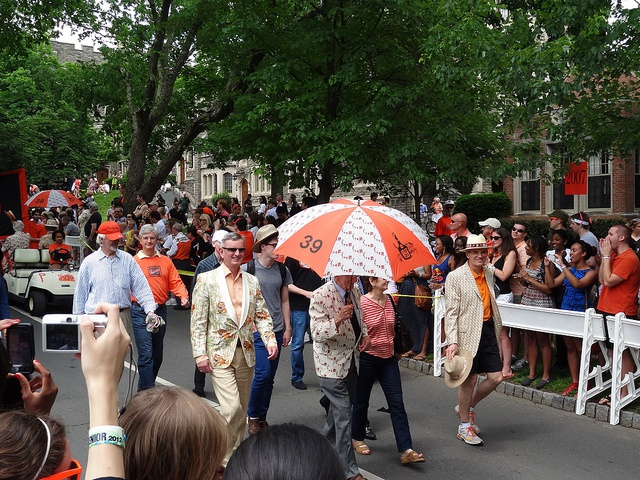Describe the objects in this image and their specific colors. I can see people in darkgreen, black, gray, and maroon tones, umbrella in darkgreen, white, and salmon tones, people in darkgreen, ivory, tan, and darkgray tones, people in darkgreen, black, lightgray, darkgray, and gray tones, and people in darkgreen, gray, black, darkgray, and lightgray tones in this image. 